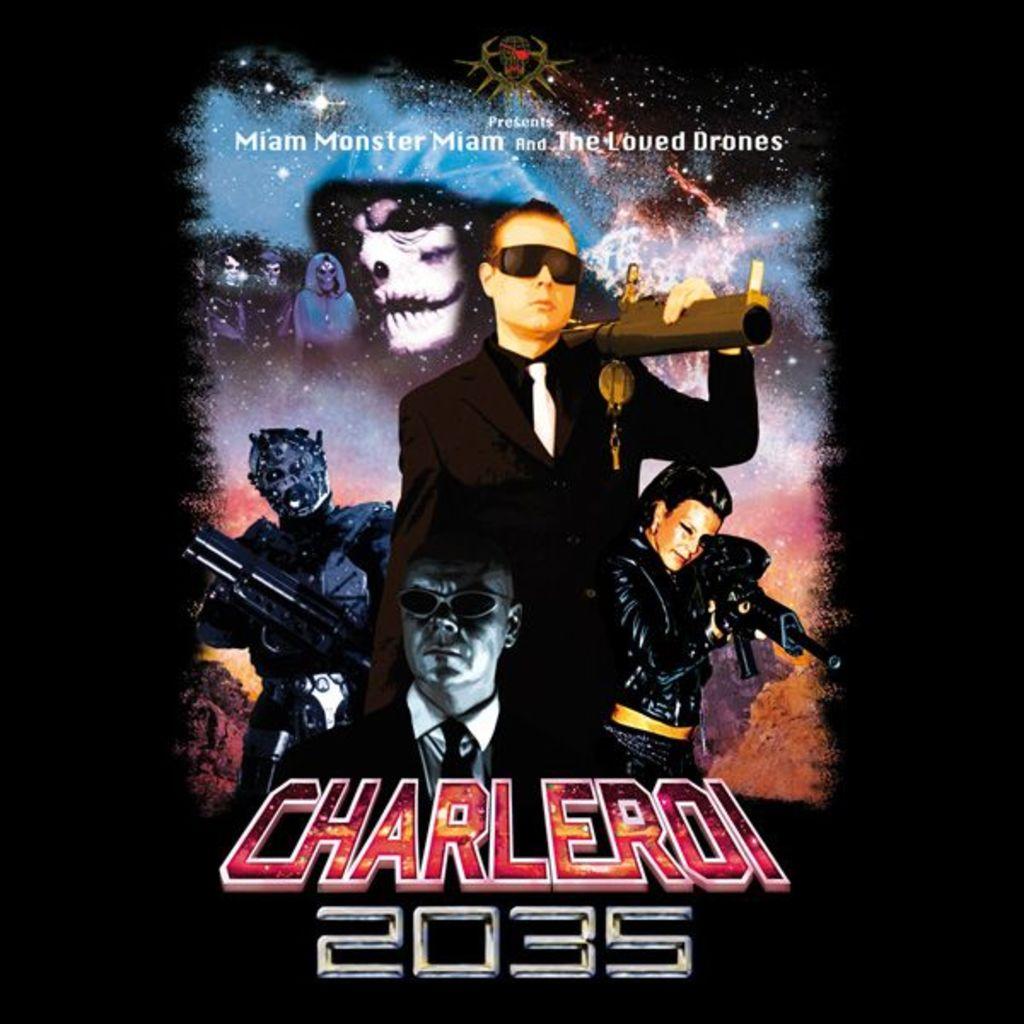What year is displayed?
Your response must be concise. 2035. What is being presented?
Your response must be concise. Charleroi 2035. 